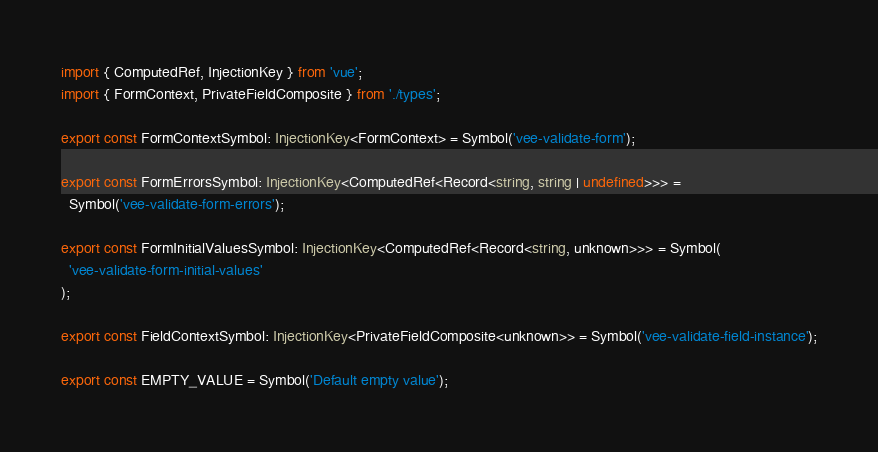Convert code to text. <code><loc_0><loc_0><loc_500><loc_500><_TypeScript_>import { ComputedRef, InjectionKey } from 'vue';
import { FormContext, PrivateFieldComposite } from './types';

export const FormContextSymbol: InjectionKey<FormContext> = Symbol('vee-validate-form');

export const FormErrorsSymbol: InjectionKey<ComputedRef<Record<string, string | undefined>>> =
  Symbol('vee-validate-form-errors');

export const FormInitialValuesSymbol: InjectionKey<ComputedRef<Record<string, unknown>>> = Symbol(
  'vee-validate-form-initial-values'
);

export const FieldContextSymbol: InjectionKey<PrivateFieldComposite<unknown>> = Symbol('vee-validate-field-instance');

export const EMPTY_VALUE = Symbol('Default empty value');
</code> 